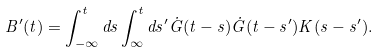<formula> <loc_0><loc_0><loc_500><loc_500>B ^ { \prime } ( t ) = \int _ { - \infty } ^ { t } d s \int _ { \infty } ^ { t } d s ^ { \prime } \dot { G } ( t - s ) \dot { G } ( t - s ^ { \prime } ) K ( s - s ^ { \prime } ) .</formula> 